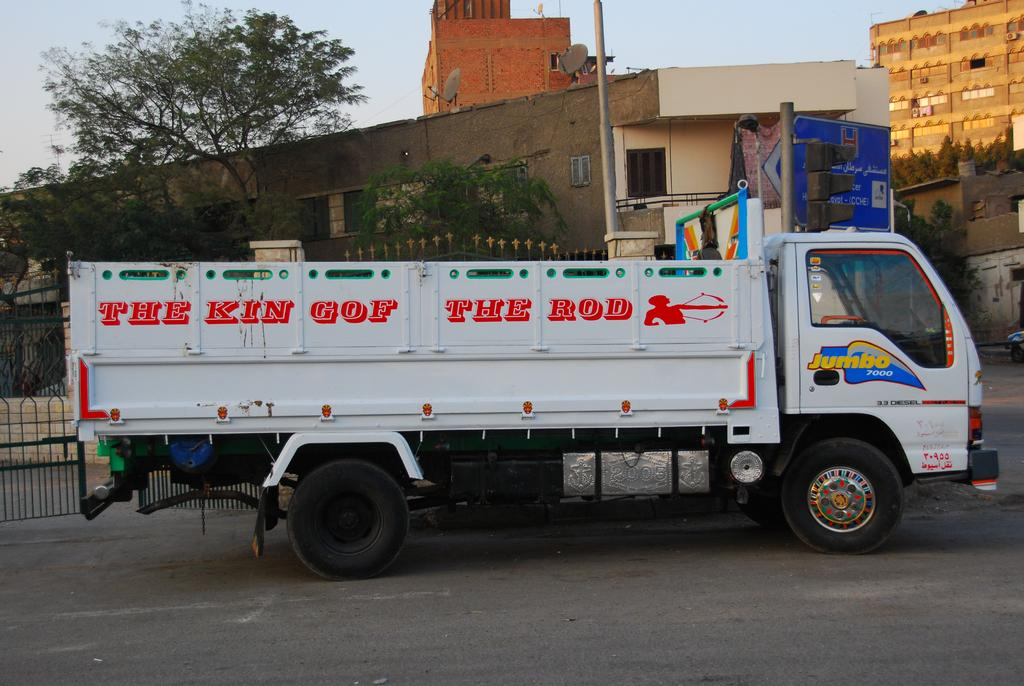Provide a one-sentence caption for the provided image. White  Jumbo seven thousand truck with the king of the rod wrote on the side. 